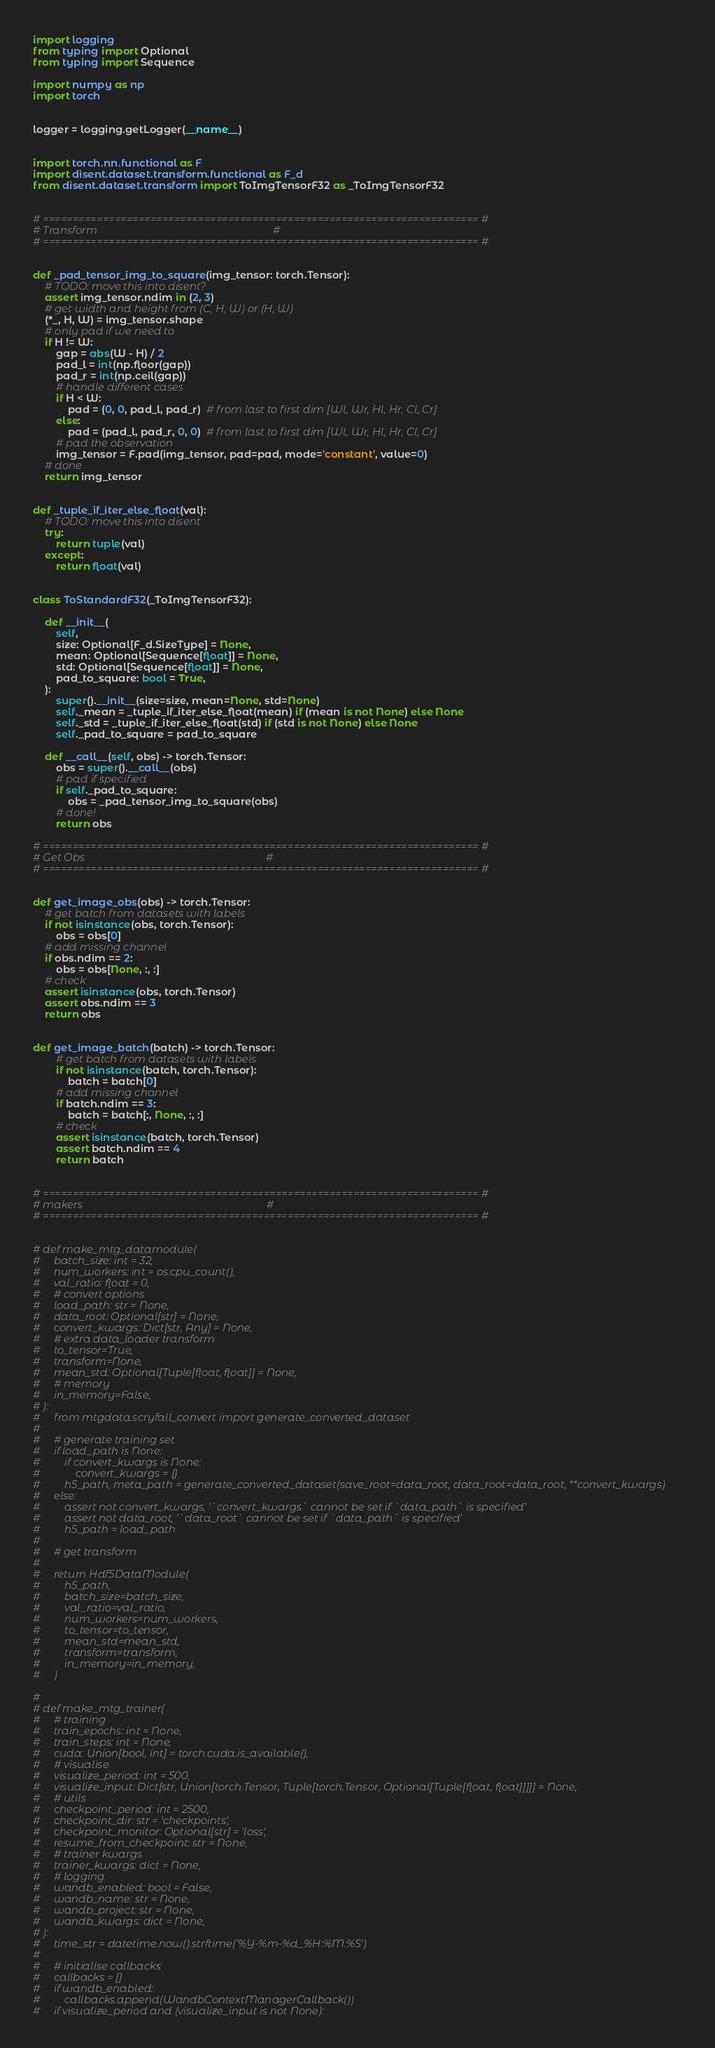<code> <loc_0><loc_0><loc_500><loc_500><_Python_>import logging
from typing import Optional
from typing import Sequence

import numpy as np
import torch


logger = logging.getLogger(__name__)


import torch.nn.functional as F
import disent.dataset.transform.functional as F_d
from disent.dataset.transform import ToImgTensorF32 as _ToImgTensorF32


# ========================================================================= #
# Transform                                                                 #
# ========================================================================= #


def _pad_tensor_img_to_square(img_tensor: torch.Tensor):
    # TODO: move this into disent?
    assert img_tensor.ndim in (2, 3)
    # get width and height from (C, H, W) or (H, W)
    (*_, H, W) = img_tensor.shape
    # only pad if we need to
    if H != W:
        gap = abs(W - H) / 2
        pad_l = int(np.floor(gap))
        pad_r = int(np.ceil(gap))
        # handle different cases
        if H < W:
            pad = (0, 0, pad_l, pad_r)  # from last to first dim [Wl, Wr, Hl, Hr, Cl, Cr]
        else:
            pad = (pad_l, pad_r, 0, 0)  # from last to first dim [Wl, Wr, Hl, Hr, Cl, Cr]
        # pad the observation
        img_tensor = F.pad(img_tensor, pad=pad, mode='constant', value=0)
    # done
    return img_tensor


def _tuple_if_iter_else_float(val):
    # TODO: move this into disent
    try:
        return tuple(val)
    except:
        return float(val)


class ToStandardF32(_ToImgTensorF32):

    def __init__(
        self,
        size: Optional[F_d.SizeType] = None,
        mean: Optional[Sequence[float]] = None,
        std: Optional[Sequence[float]] = None,
        pad_to_square: bool = True,
    ):
        super().__init__(size=size, mean=None, std=None)
        self._mean = _tuple_if_iter_else_float(mean) if (mean is not None) else None
        self._std = _tuple_if_iter_else_float(std) if (std is not None) else None
        self._pad_to_square = pad_to_square

    def __call__(self, obs) -> torch.Tensor:
        obs = super().__call__(obs)
        # pad if specified
        if self._pad_to_square:
            obs = _pad_tensor_img_to_square(obs)
        # done!
        return obs

# ========================================================================= #
# Get Obs                                                                   #
# ========================================================================= #


def get_image_obs(obs) -> torch.Tensor:
    # get batch from datasets with labels
    if not isinstance(obs, torch.Tensor):
        obs = obs[0]
    # add missing channel
    if obs.ndim == 2:
        obs = obs[None, :, :]
    # check
    assert isinstance(obs, torch.Tensor)
    assert obs.ndim == 3
    return obs


def get_image_batch(batch) -> torch.Tensor:
        # get batch from datasets with labels
        if not isinstance(batch, torch.Tensor):
            batch = batch[0]
        # add missing channel
        if batch.ndim == 3:
            batch = batch[:, None, :, :]
        # check
        assert isinstance(batch, torch.Tensor)
        assert batch.ndim == 4
        return batch


# ========================================================================= #
# makers                                                                    #
# ========================================================================= #


# def make_mtg_datamodule(
#     batch_size: int = 32,
#     num_workers: int = os.cpu_count(),
#     val_ratio: float = 0,
#     # convert options
#     load_path: str = None,
#     data_root: Optional[str] = None,
#     convert_kwargs: Dict[str, Any] = None,
#     # extra data_loader transform
#     to_tensor=True,
#     transform=None,
#     mean_std: Optional[Tuple[float, float]] = None,
#     # memory
#     in_memory=False,
# ):
#     from mtgdata.scryfall_convert import generate_converted_dataset
#
#     # generate training set
#     if load_path is None:
#         if convert_kwargs is None:
#             convert_kwargs = {}
#         h5_path, meta_path = generate_converted_dataset(save_root=data_root, data_root=data_root, **convert_kwargs)
#     else:
#         assert not convert_kwargs, '`convert_kwargs` cannot be set if `data_path` is specified'
#         assert not data_root, '`data_root` cannot be set if `data_path` is specified'
#         h5_path = load_path
#
#     # get transform
#
#     return Hdf5DataModule(
#         h5_path,
#         batch_size=batch_size,
#         val_ratio=val_ratio,
#         num_workers=num_workers,
#         to_tensor=to_tensor,
#         mean_std=mean_std,
#         transform=transform,
#         in_memory=in_memory,
#     )

#
# def make_mtg_trainer(
#     # training
#     train_epochs: int = None,
#     train_steps: int = None,
#     cuda: Union[bool, int] = torch.cuda.is_available(),
#     # visualise
#     visualize_period: int = 500,
#     visualize_input: Dict[str, Union[torch.Tensor, Tuple[torch.Tensor, Optional[Tuple[float, float]]]]] = None,
#     # utils
#     checkpoint_period: int = 2500,
#     checkpoint_dir: str = 'checkpoints',
#     checkpoint_monitor: Optional[str] = 'loss',
#     resume_from_checkpoint: str = None,
#     # trainer kwargs
#     trainer_kwargs: dict = None,
#     # logging
#     wandb_enabled: bool = False,
#     wandb_name: str = None,
#     wandb_project: str = None,
#     wandb_kwargs: dict = None,
# ):
#     time_str = datetime.now().strftime('%Y-%m-%d_%H:%M:%S')
#
#     # initialise callbacks
#     callbacks = []
#     if wandb_enabled:
#         callbacks.append(WandbContextManagerCallback())
#     if visualize_period and (visualize_input is not None):</code> 